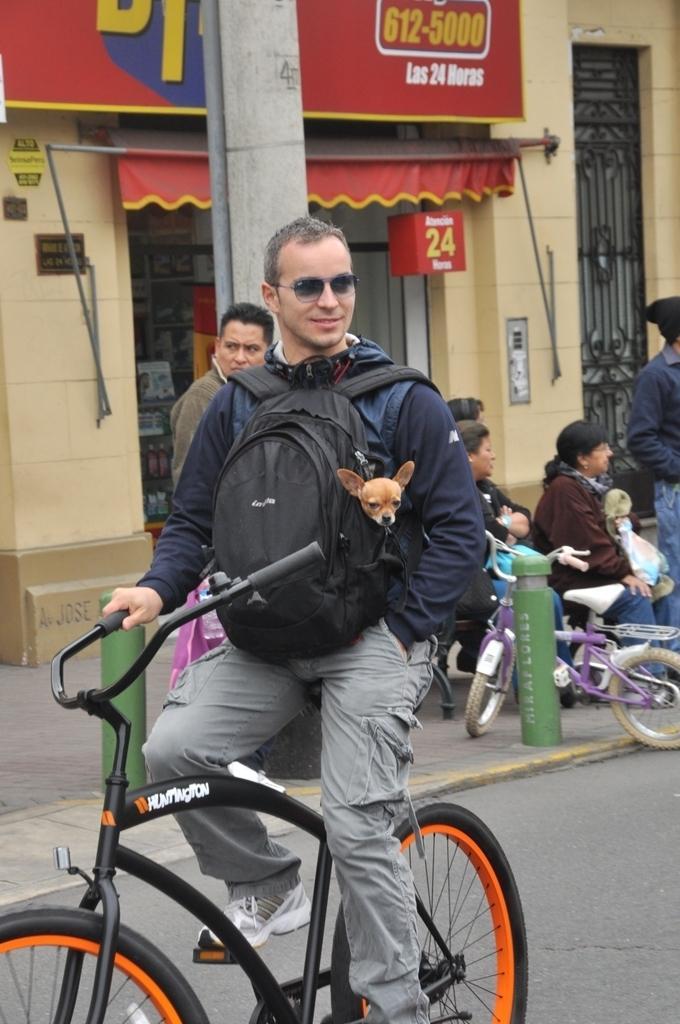Please provide a concise description of this image. In this image there are few people. In the front the man is riding bicycle and wearing a bag pack and a dog is kept in that bag pack. In the background there are three people sitting and two people are standing. There is a building and shop at the back. 